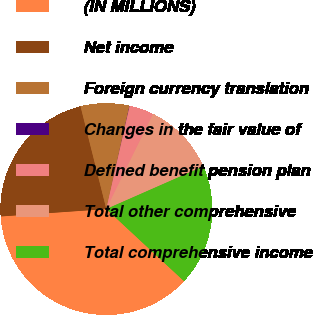<chart> <loc_0><loc_0><loc_500><loc_500><pie_chart><fcel>(IN MILLIONS)<fcel>Net income<fcel>Foreign currency translation<fcel>Changes in the fair value of<fcel>Defined benefit pension plan<fcel>Total other comprehensive<fcel>Total comprehensive income<nl><fcel>36.98%<fcel>22.2%<fcel>7.43%<fcel>0.04%<fcel>3.73%<fcel>11.12%<fcel>18.51%<nl></chart> 